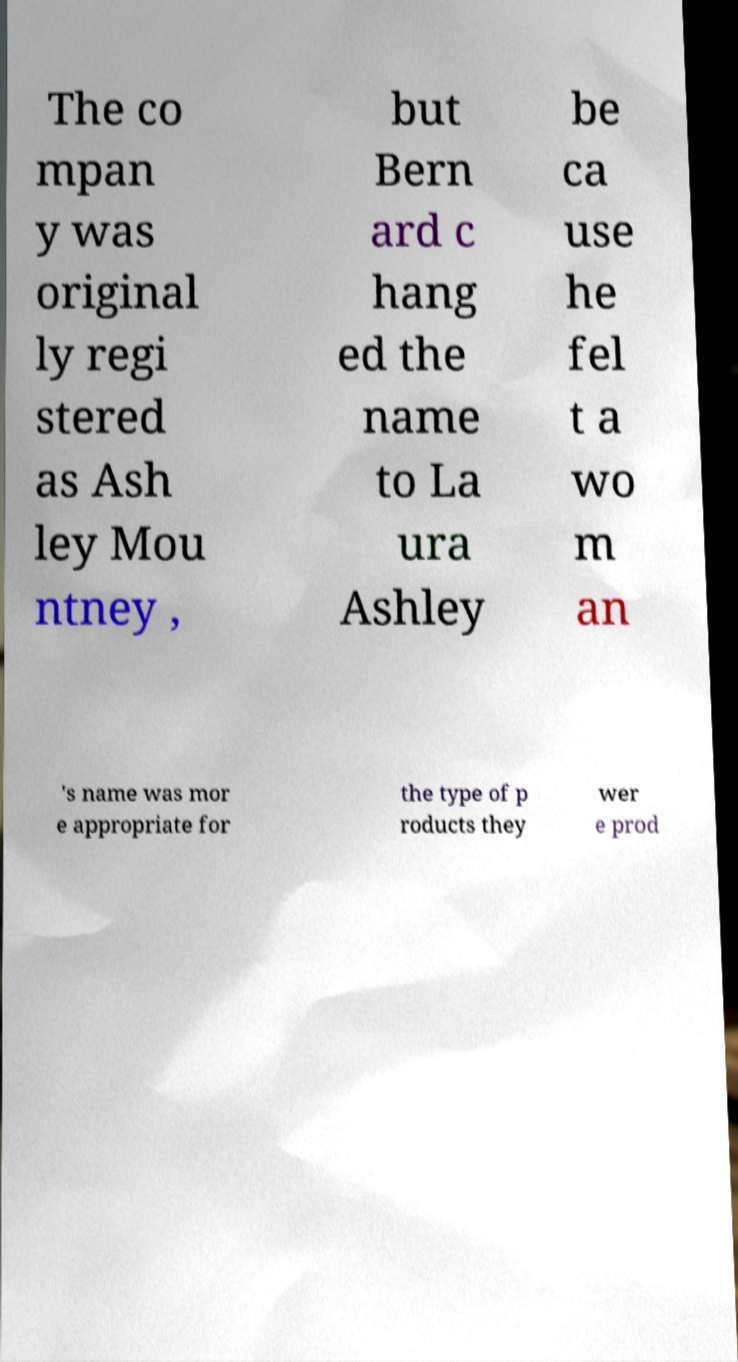What messages or text are displayed in this image? I need them in a readable, typed format. The co mpan y was original ly regi stered as Ash ley Mou ntney , but Bern ard c hang ed the name to La ura Ashley be ca use he fel t a wo m an 's name was mor e appropriate for the type of p roducts they wer e prod 